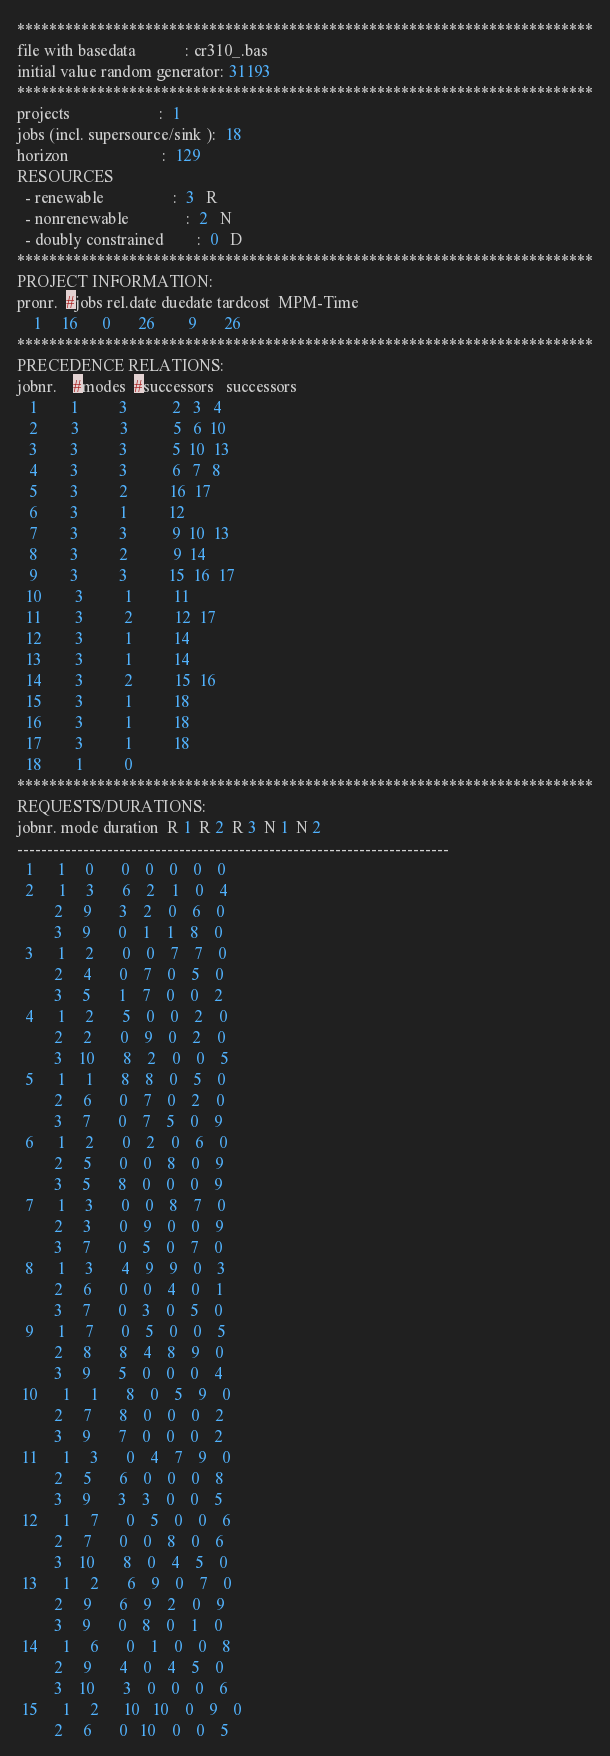<code> <loc_0><loc_0><loc_500><loc_500><_ObjectiveC_>************************************************************************
file with basedata            : cr310_.bas
initial value random generator: 31193
************************************************************************
projects                      :  1
jobs (incl. supersource/sink ):  18
horizon                       :  129
RESOURCES
  - renewable                 :  3   R
  - nonrenewable              :  2   N
  - doubly constrained        :  0   D
************************************************************************
PROJECT INFORMATION:
pronr.  #jobs rel.date duedate tardcost  MPM-Time
    1     16      0       26        9       26
************************************************************************
PRECEDENCE RELATIONS:
jobnr.    #modes  #successors   successors
   1        1          3           2   3   4
   2        3          3           5   6  10
   3        3          3           5  10  13
   4        3          3           6   7   8
   5        3          2          16  17
   6        3          1          12
   7        3          3           9  10  13
   8        3          2           9  14
   9        3          3          15  16  17
  10        3          1          11
  11        3          2          12  17
  12        3          1          14
  13        3          1          14
  14        3          2          15  16
  15        3          1          18
  16        3          1          18
  17        3          1          18
  18        1          0        
************************************************************************
REQUESTS/DURATIONS:
jobnr. mode duration  R 1  R 2  R 3  N 1  N 2
------------------------------------------------------------------------
  1      1     0       0    0    0    0    0
  2      1     3       6    2    1    0    4
         2     9       3    2    0    6    0
         3     9       0    1    1    8    0
  3      1     2       0    0    7    7    0
         2     4       0    7    0    5    0
         3     5       1    7    0    0    2
  4      1     2       5    0    0    2    0
         2     2       0    9    0    2    0
         3    10       8    2    0    0    5
  5      1     1       8    8    0    5    0
         2     6       0    7    0    2    0
         3     7       0    7    5    0    9
  6      1     2       0    2    0    6    0
         2     5       0    0    8    0    9
         3     5       8    0    0    0    9
  7      1     3       0    0    8    7    0
         2     3       0    9    0    0    9
         3     7       0    5    0    7    0
  8      1     3       4    9    9    0    3
         2     6       0    0    4    0    1
         3     7       0    3    0    5    0
  9      1     7       0    5    0    0    5
         2     8       8    4    8    9    0
         3     9       5    0    0    0    4
 10      1     1       8    0    5    9    0
         2     7       8    0    0    0    2
         3     9       7    0    0    0    2
 11      1     3       0    4    7    9    0
         2     5       6    0    0    0    8
         3     9       3    3    0    0    5
 12      1     7       0    5    0    0    6
         2     7       0    0    8    0    6
         3    10       8    0    4    5    0
 13      1     2       6    9    0    7    0
         2     9       6    9    2    0    9
         3     9       0    8    0    1    0
 14      1     6       0    1    0    0    8
         2     9       4    0    4    5    0
         3    10       3    0    0    0    6
 15      1     2      10   10    0    9    0
         2     6       0   10    0    0    5</code> 